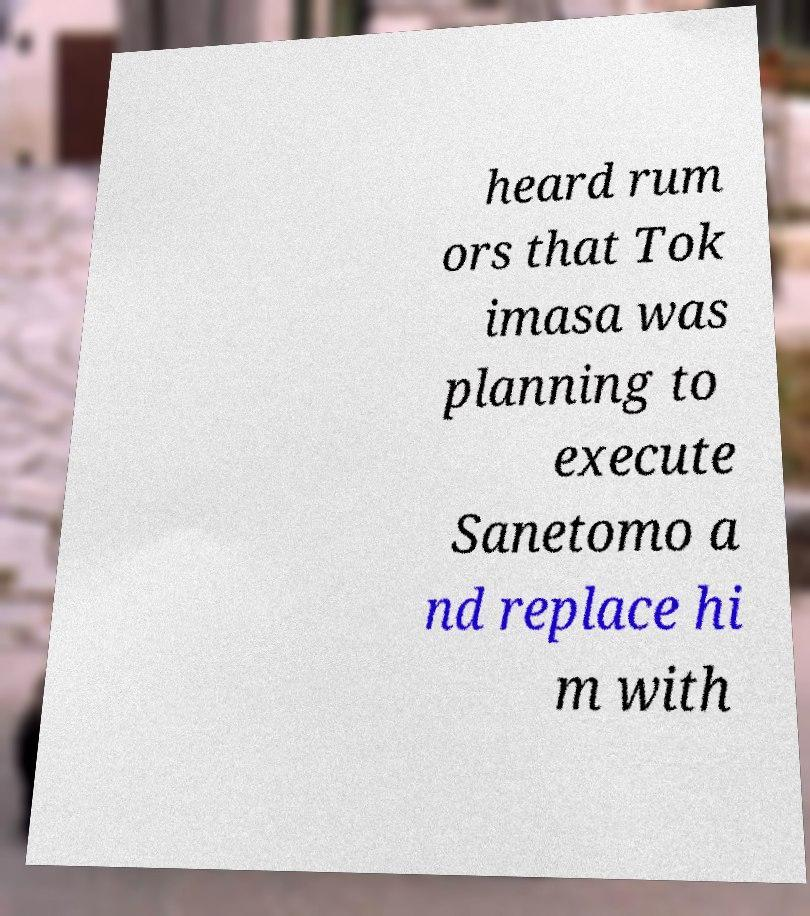There's text embedded in this image that I need extracted. Can you transcribe it verbatim? heard rum ors that Tok imasa was planning to execute Sanetomo a nd replace hi m with 